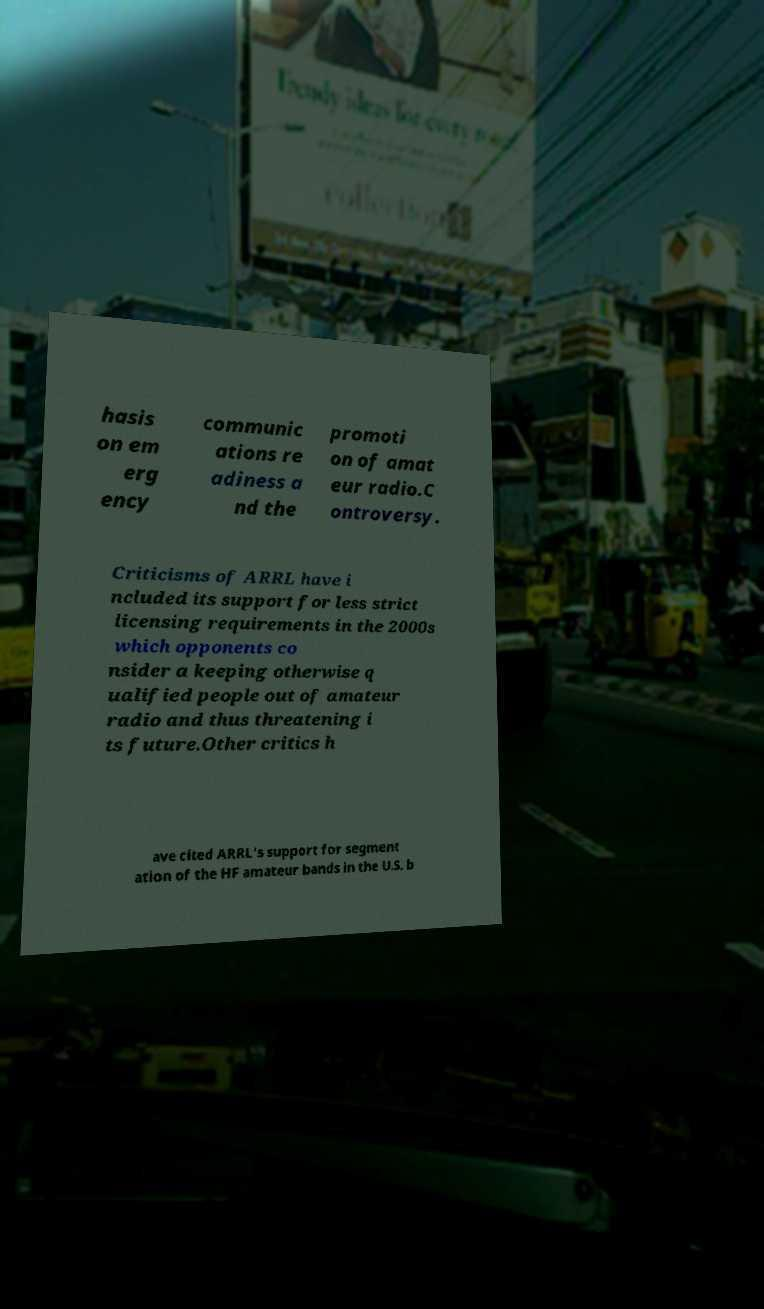Please read and relay the text visible in this image. What does it say? hasis on em erg ency communic ations re adiness a nd the promoti on of amat eur radio.C ontroversy. Criticisms of ARRL have i ncluded its support for less strict licensing requirements in the 2000s which opponents co nsider a keeping otherwise q ualified people out of amateur radio and thus threatening i ts future.Other critics h ave cited ARRL's support for segment ation of the HF amateur bands in the U.S. b 